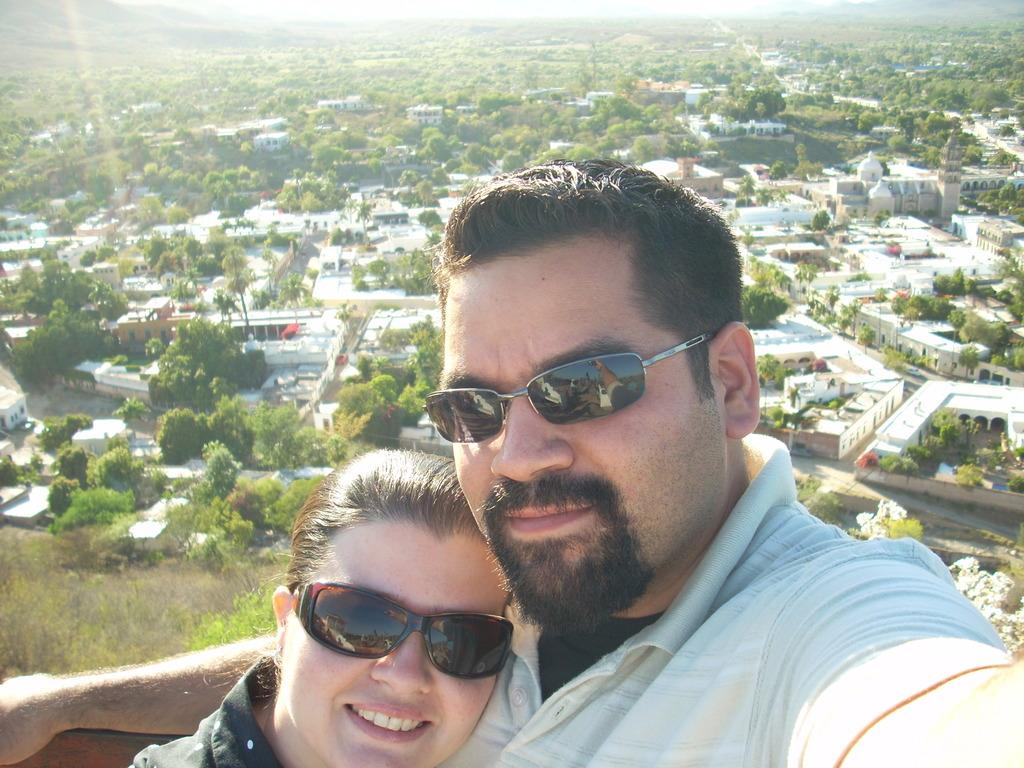How many people are present in the image? There are two persons in the image. Where are the persons located in the image? The persons are at the bottom of the image. What can be seen in the background of the image? There are buildings and trees in the background of the image. What is visible at the top of the image? The sky is visible at the top of the image. What type of jeans is the person wearing in the image? There is no information about the type of jeans the person is wearing in the image. Can you tell me how many rifles are visible in the image? There are no rifles present in the image. 